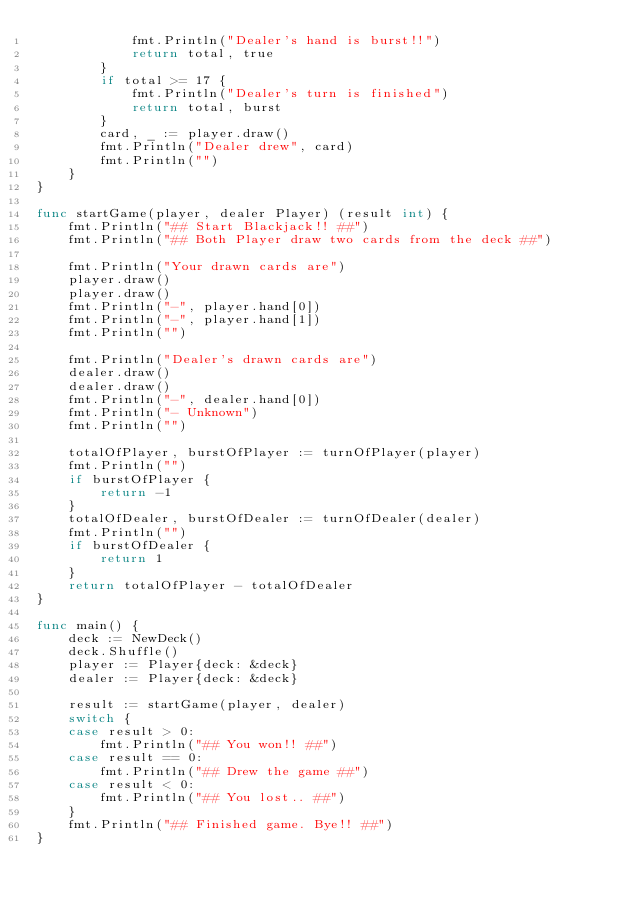<code> <loc_0><loc_0><loc_500><loc_500><_Go_>			fmt.Println("Dealer's hand is burst!!")
			return total, true
		}
		if total >= 17 {
			fmt.Println("Dealer's turn is finished")
			return total, burst
		}
		card, _ := player.draw()
		fmt.Println("Dealer drew", card)
		fmt.Println("")
	}
}

func startGame(player, dealer Player) (result int) {
	fmt.Println("## Start Blackjack!! ##")
	fmt.Println("## Both Player draw two cards from the deck ##")

	fmt.Println("Your drawn cards are")
	player.draw()
	player.draw()
	fmt.Println("-", player.hand[0])
	fmt.Println("-", player.hand[1])
	fmt.Println("")

	fmt.Println("Dealer's drawn cards are")
	dealer.draw()
	dealer.draw()
	fmt.Println("-", dealer.hand[0])
	fmt.Println("- Unknown")
	fmt.Println("")

	totalOfPlayer, burstOfPlayer := turnOfPlayer(player)
	fmt.Println("")
	if burstOfPlayer {
		return -1
	}
	totalOfDealer, burstOfDealer := turnOfDealer(dealer)
	fmt.Println("")
	if burstOfDealer {
		return 1
	}
	return totalOfPlayer - totalOfDealer
}

func main() {
	deck := NewDeck()
	deck.Shuffle()
	player := Player{deck: &deck}
	dealer := Player{deck: &deck}

	result := startGame(player, dealer)
	switch {
	case result > 0:
		fmt.Println("## You won!! ##")
	case result == 0:
		fmt.Println("## Drew the game ##")
	case result < 0:
		fmt.Println("## You lost.. ##")
	}
	fmt.Println("## Finished game. Bye!! ##")
}
</code> 